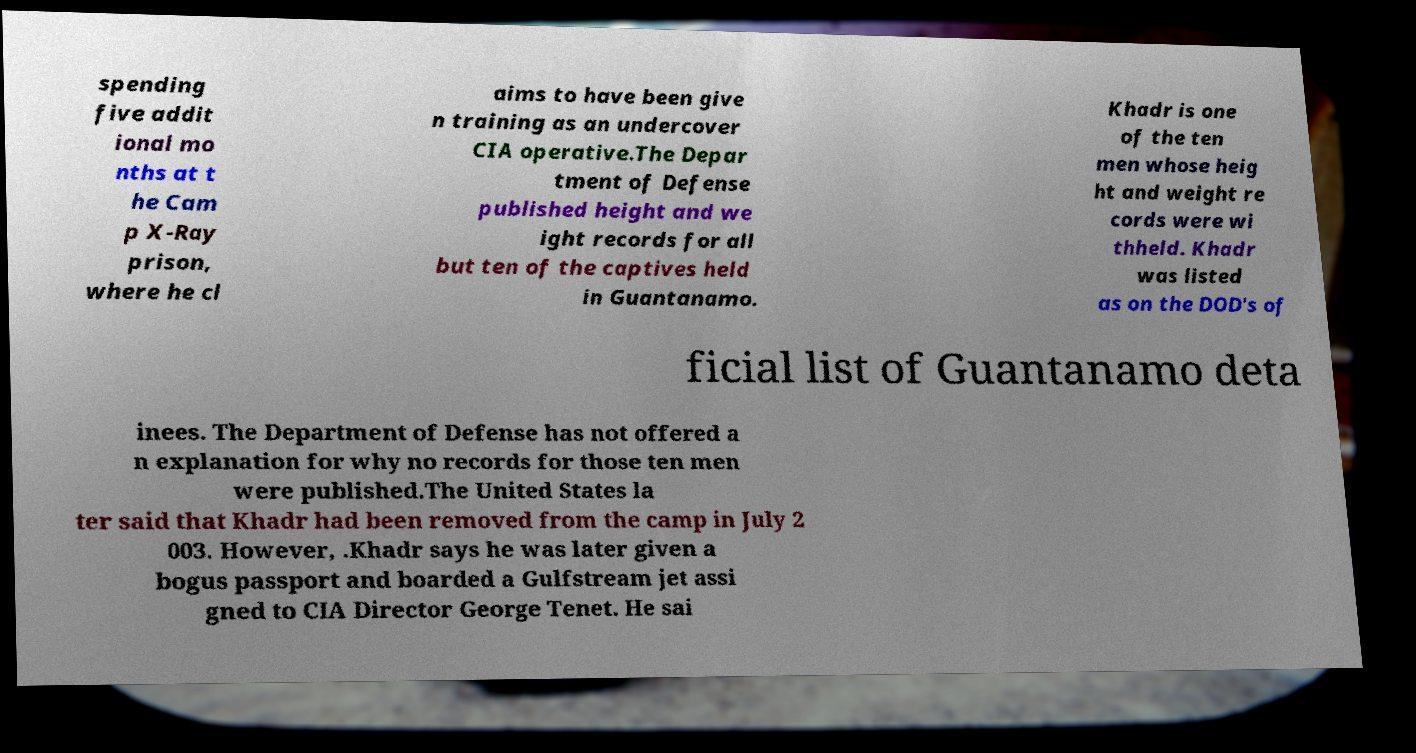What messages or text are displayed in this image? I need them in a readable, typed format. spending five addit ional mo nths at t he Cam p X-Ray prison, where he cl aims to have been give n training as an undercover CIA operative.The Depar tment of Defense published height and we ight records for all but ten of the captives held in Guantanamo. Khadr is one of the ten men whose heig ht and weight re cords were wi thheld. Khadr was listed as on the DOD's of ficial list of Guantanamo deta inees. The Department of Defense has not offered a n explanation for why no records for those ten men were published.The United States la ter said that Khadr had been removed from the camp in July 2 003. However, .Khadr says he was later given a bogus passport and boarded a Gulfstream jet assi gned to CIA Director George Tenet. He sai 